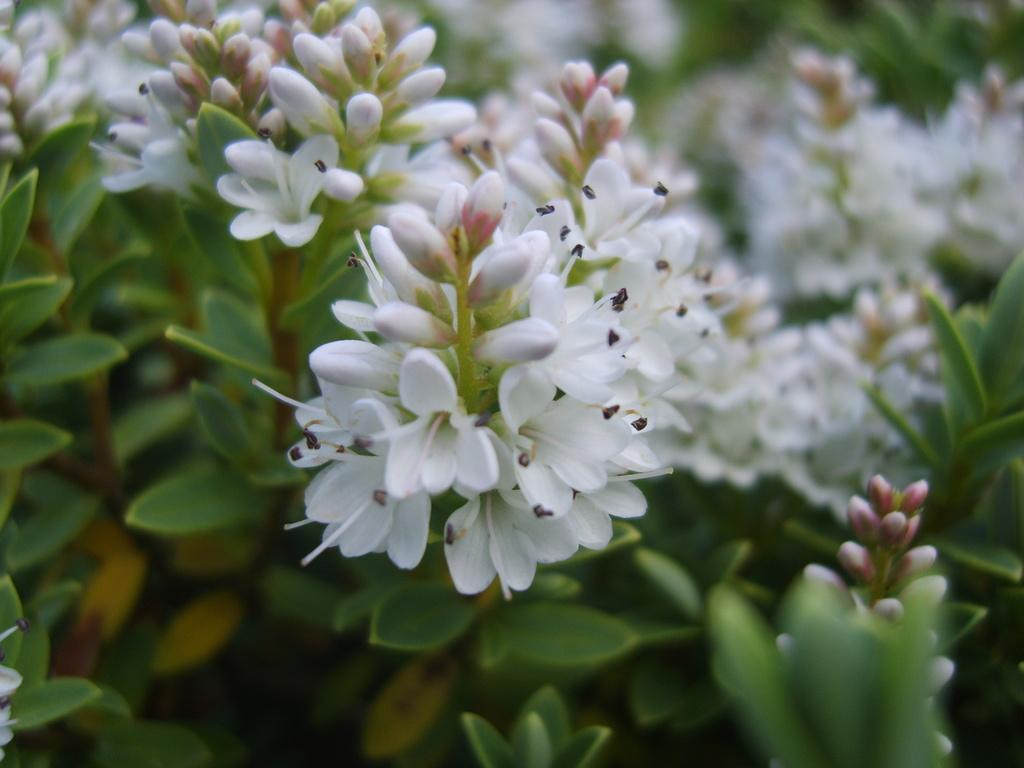What types of living organisms can be seen in the image? The image contains plants. What specific part of the plants is the main focus of the image? There are flowers in the middle of the image. What is the color of the flowers? The flowers are white in color. What type of base can be seen supporting the can in the image? There is no can present in the image, so there is no base supporting it. 